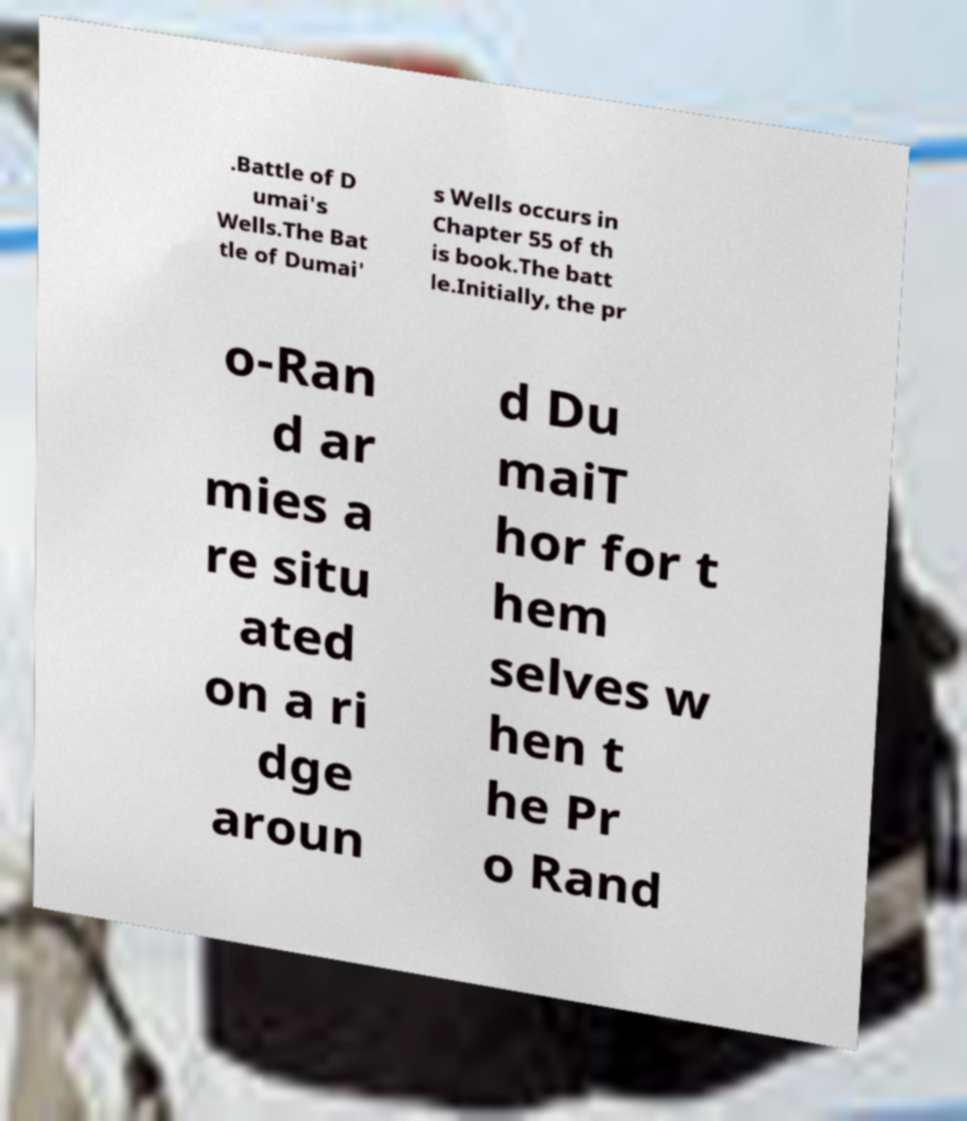Could you extract and type out the text from this image? .Battle of D umai's Wells.The Bat tle of Dumai' s Wells occurs in Chapter 55 of th is book.The batt le.Initially, the pr o-Ran d ar mies a re situ ated on a ri dge aroun d Du maiT hor for t hem selves w hen t he Pr o Rand 